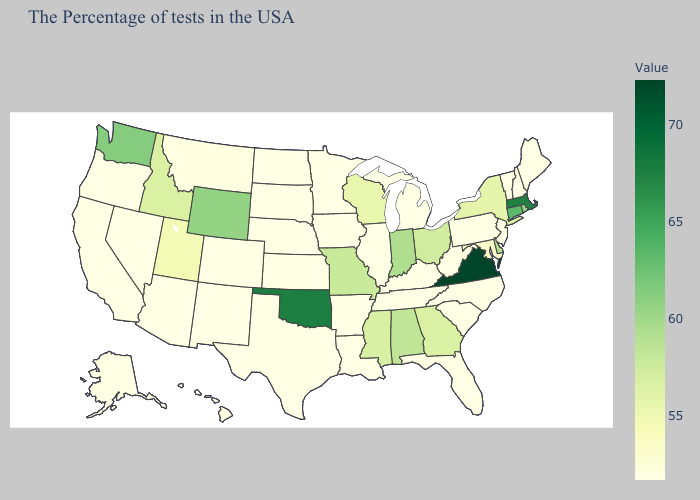Does California have the highest value in the USA?
Keep it brief. No. Among the states that border New Jersey , does New York have the lowest value?
Concise answer only. No. Which states hav the highest value in the South?
Give a very brief answer. Virginia. Among the states that border Alabama , does Florida have the lowest value?
Concise answer only. Yes. Which states have the lowest value in the USA?
Answer briefly. Maine, New Hampshire, Vermont, New Jersey, Pennsylvania, North Carolina, South Carolina, West Virginia, Florida, Michigan, Kentucky, Tennessee, Illinois, Louisiana, Arkansas, Minnesota, Iowa, Kansas, Nebraska, Texas, South Dakota, North Dakota, Colorado, New Mexico, Arizona, Nevada, California, Oregon, Alaska, Hawaii. Does New York have the highest value in the Northeast?
Short answer required. No. Does Minnesota have a lower value than Missouri?
Short answer required. Yes. 